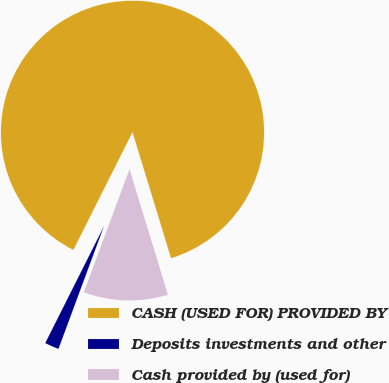Convert chart. <chart><loc_0><loc_0><loc_500><loc_500><pie_chart><fcel>CASH (USED FOR) PROVIDED BY<fcel>Deposits investments and other<fcel>Cash provided by (used for)<nl><fcel>87.87%<fcel>1.76%<fcel>10.37%<nl></chart> 